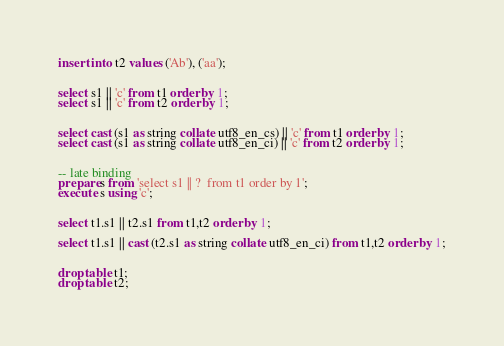Convert code to text. <code><loc_0><loc_0><loc_500><loc_500><_SQL_>
insert into t2 values ('Ab'), ('aa');


select s1 || 'c' from t1 order by 1;
select s1 || 'c' from t2 order by 1;


select cast (s1 as string collate utf8_en_cs) || 'c' from t1 order by 1;
select cast (s1 as string collate utf8_en_ci) || 'c' from t2 order by 1;


-- late binding
prepare s from 'select s1 || ?  from t1 order by 1';
execute s using 'c';


select t1.s1 || t2.s1 from t1,t2 order by 1;

select t1.s1 || cast (t2.s1 as string collate utf8_en_ci) from t1,t2 order by 1;


drop table t1;
drop table t2;
</code> 